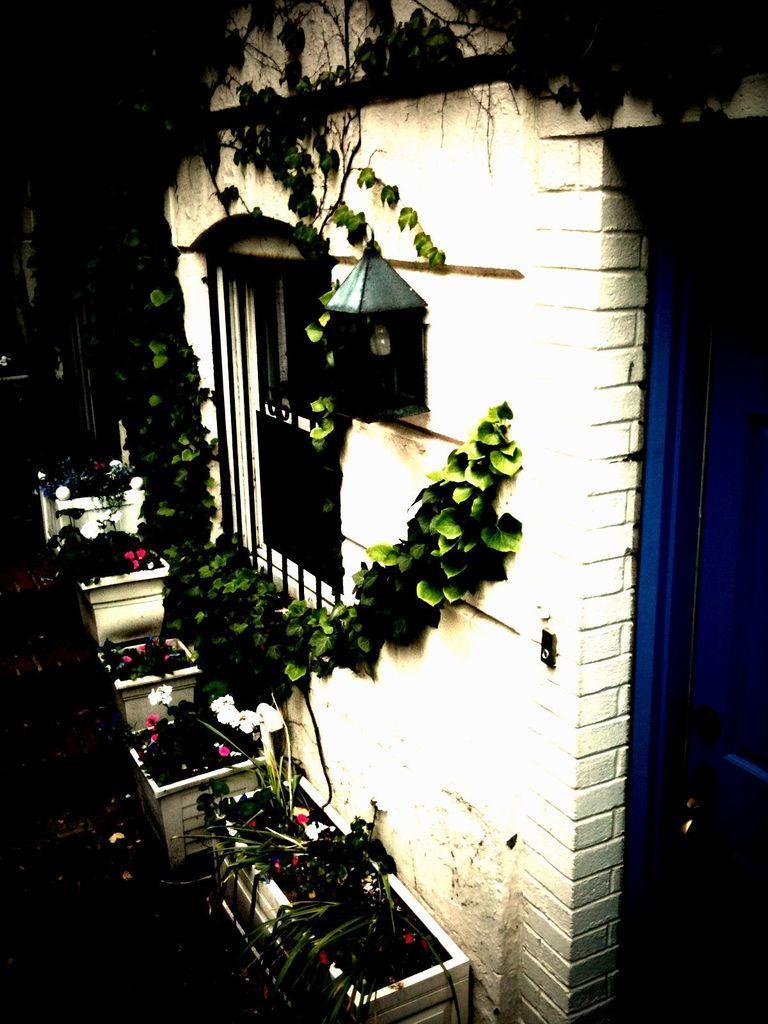Please provide a concise description of this image. In this image there is a wall, there is a window, there is a door towards the right of the image, there are creepers on the wall, there is a light on the wall, there is floor towards the bottom of the image, there are flower pots on the floor, there are plants, there are flowers, the background of the image is dark. 